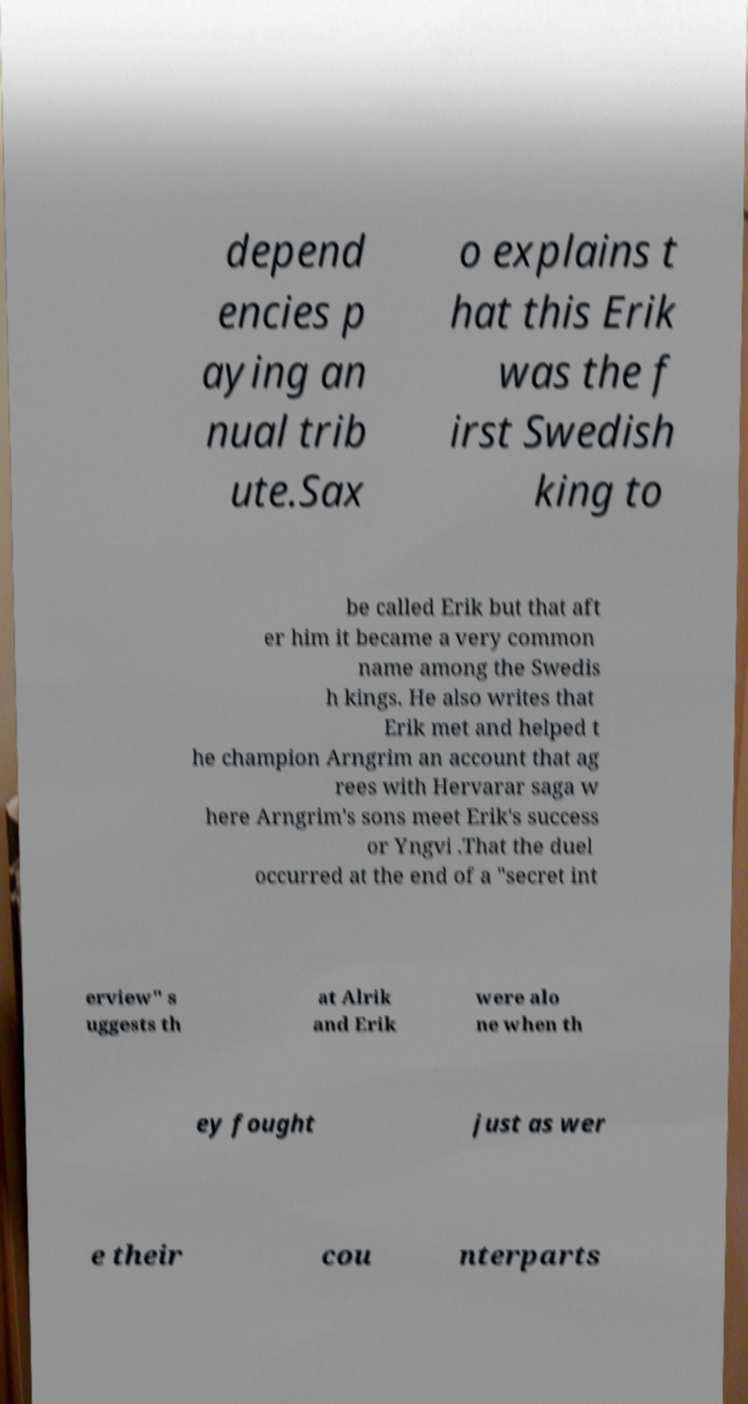There's text embedded in this image that I need extracted. Can you transcribe it verbatim? depend encies p aying an nual trib ute.Sax o explains t hat this Erik was the f irst Swedish king to be called Erik but that aft er him it became a very common name among the Swedis h kings. He also writes that Erik met and helped t he champion Arngrim an account that ag rees with Hervarar saga w here Arngrim's sons meet Erik's success or Yngvi .That the duel occurred at the end of a "secret int erview" s uggests th at Alrik and Erik were alo ne when th ey fought just as wer e their cou nterparts 